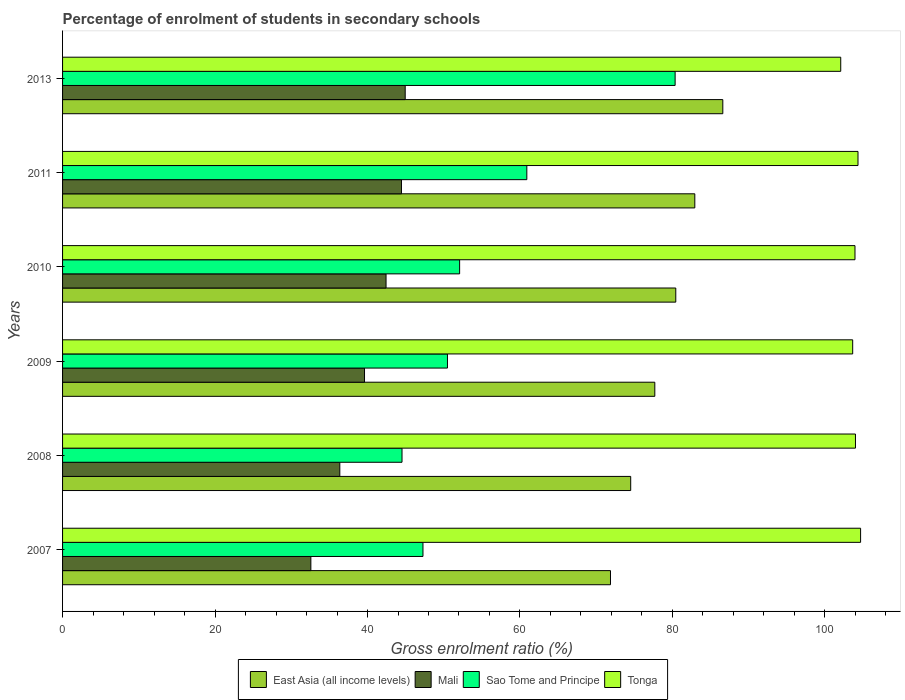How many different coloured bars are there?
Your answer should be compact. 4. How many groups of bars are there?
Provide a short and direct response. 6. Are the number of bars per tick equal to the number of legend labels?
Make the answer very short. Yes. Are the number of bars on each tick of the Y-axis equal?
Provide a short and direct response. Yes. How many bars are there on the 2nd tick from the top?
Keep it short and to the point. 4. How many bars are there on the 3rd tick from the bottom?
Offer a very short reply. 4. In how many cases, is the number of bars for a given year not equal to the number of legend labels?
Your response must be concise. 0. What is the percentage of students enrolled in secondary schools in Sao Tome and Principe in 2010?
Provide a short and direct response. 52.08. Across all years, what is the maximum percentage of students enrolled in secondary schools in East Asia (all income levels)?
Provide a short and direct response. 86.61. Across all years, what is the minimum percentage of students enrolled in secondary schools in Sao Tome and Principe?
Make the answer very short. 44.53. In which year was the percentage of students enrolled in secondary schools in Sao Tome and Principe maximum?
Offer a very short reply. 2013. In which year was the percentage of students enrolled in secondary schools in Tonga minimum?
Your answer should be compact. 2013. What is the total percentage of students enrolled in secondary schools in Sao Tome and Principe in the graph?
Give a very brief answer. 335.63. What is the difference between the percentage of students enrolled in secondary schools in Sao Tome and Principe in 2007 and that in 2010?
Your answer should be very brief. -4.81. What is the difference between the percentage of students enrolled in secondary schools in East Asia (all income levels) in 2009 and the percentage of students enrolled in secondary schools in Tonga in 2013?
Provide a short and direct response. -24.39. What is the average percentage of students enrolled in secondary schools in East Asia (all income levels) per year?
Give a very brief answer. 79.01. In the year 2007, what is the difference between the percentage of students enrolled in secondary schools in Sao Tome and Principe and percentage of students enrolled in secondary schools in East Asia (all income levels)?
Offer a terse response. -24.6. In how many years, is the percentage of students enrolled in secondary schools in Mali greater than 76 %?
Ensure brevity in your answer.  0. What is the ratio of the percentage of students enrolled in secondary schools in Sao Tome and Principe in 2008 to that in 2010?
Your answer should be very brief. 0.85. Is the percentage of students enrolled in secondary schools in Sao Tome and Principe in 2007 less than that in 2008?
Your response must be concise. No. Is the difference between the percentage of students enrolled in secondary schools in Sao Tome and Principe in 2008 and 2010 greater than the difference between the percentage of students enrolled in secondary schools in East Asia (all income levels) in 2008 and 2010?
Give a very brief answer. No. What is the difference between the highest and the second highest percentage of students enrolled in secondary schools in East Asia (all income levels)?
Make the answer very short. 3.67. What is the difference between the highest and the lowest percentage of students enrolled in secondary schools in Mali?
Your answer should be compact. 12.38. Is the sum of the percentage of students enrolled in secondary schools in Sao Tome and Principe in 2007 and 2008 greater than the maximum percentage of students enrolled in secondary schools in Tonga across all years?
Keep it short and to the point. No. Is it the case that in every year, the sum of the percentage of students enrolled in secondary schools in East Asia (all income levels) and percentage of students enrolled in secondary schools in Sao Tome and Principe is greater than the sum of percentage of students enrolled in secondary schools in Mali and percentage of students enrolled in secondary schools in Tonga?
Offer a very short reply. No. What does the 2nd bar from the top in 2009 represents?
Ensure brevity in your answer.  Sao Tome and Principe. What does the 3rd bar from the bottom in 2013 represents?
Offer a terse response. Sao Tome and Principe. Is it the case that in every year, the sum of the percentage of students enrolled in secondary schools in Sao Tome and Principe and percentage of students enrolled in secondary schools in Tonga is greater than the percentage of students enrolled in secondary schools in Mali?
Offer a terse response. Yes. Are the values on the major ticks of X-axis written in scientific E-notation?
Your answer should be very brief. No. Does the graph contain any zero values?
Ensure brevity in your answer.  No. Does the graph contain grids?
Keep it short and to the point. No. Where does the legend appear in the graph?
Offer a terse response. Bottom center. How many legend labels are there?
Your response must be concise. 4. How are the legend labels stacked?
Offer a very short reply. Horizontal. What is the title of the graph?
Keep it short and to the point. Percentage of enrolment of students in secondary schools. What is the label or title of the Y-axis?
Provide a succinct answer. Years. What is the Gross enrolment ratio (%) of East Asia (all income levels) in 2007?
Offer a terse response. 71.87. What is the Gross enrolment ratio (%) in Mali in 2007?
Make the answer very short. 32.57. What is the Gross enrolment ratio (%) in Sao Tome and Principe in 2007?
Your answer should be very brief. 47.28. What is the Gross enrolment ratio (%) of Tonga in 2007?
Offer a very short reply. 104.68. What is the Gross enrolment ratio (%) in East Asia (all income levels) in 2008?
Keep it short and to the point. 74.53. What is the Gross enrolment ratio (%) of Mali in 2008?
Make the answer very short. 36.37. What is the Gross enrolment ratio (%) of Sao Tome and Principe in 2008?
Make the answer very short. 44.53. What is the Gross enrolment ratio (%) of Tonga in 2008?
Keep it short and to the point. 104.01. What is the Gross enrolment ratio (%) of East Asia (all income levels) in 2009?
Make the answer very short. 77.69. What is the Gross enrolment ratio (%) of Mali in 2009?
Provide a succinct answer. 39.61. What is the Gross enrolment ratio (%) in Sao Tome and Principe in 2009?
Provide a short and direct response. 50.49. What is the Gross enrolment ratio (%) of Tonga in 2009?
Your response must be concise. 103.64. What is the Gross enrolment ratio (%) of East Asia (all income levels) in 2010?
Ensure brevity in your answer.  80.44. What is the Gross enrolment ratio (%) of Mali in 2010?
Give a very brief answer. 42.43. What is the Gross enrolment ratio (%) in Sao Tome and Principe in 2010?
Your answer should be compact. 52.08. What is the Gross enrolment ratio (%) of Tonga in 2010?
Give a very brief answer. 103.95. What is the Gross enrolment ratio (%) in East Asia (all income levels) in 2011?
Offer a very short reply. 82.94. What is the Gross enrolment ratio (%) of Mali in 2011?
Ensure brevity in your answer.  44.46. What is the Gross enrolment ratio (%) in Sao Tome and Principe in 2011?
Your answer should be very brief. 60.9. What is the Gross enrolment ratio (%) of Tonga in 2011?
Keep it short and to the point. 104.34. What is the Gross enrolment ratio (%) of East Asia (all income levels) in 2013?
Provide a short and direct response. 86.61. What is the Gross enrolment ratio (%) of Mali in 2013?
Give a very brief answer. 44.95. What is the Gross enrolment ratio (%) in Sao Tome and Principe in 2013?
Provide a short and direct response. 80.35. What is the Gross enrolment ratio (%) in Tonga in 2013?
Your response must be concise. 102.08. Across all years, what is the maximum Gross enrolment ratio (%) of East Asia (all income levels)?
Give a very brief answer. 86.61. Across all years, what is the maximum Gross enrolment ratio (%) of Mali?
Make the answer very short. 44.95. Across all years, what is the maximum Gross enrolment ratio (%) of Sao Tome and Principe?
Your answer should be very brief. 80.35. Across all years, what is the maximum Gross enrolment ratio (%) of Tonga?
Provide a short and direct response. 104.68. Across all years, what is the minimum Gross enrolment ratio (%) in East Asia (all income levels)?
Offer a terse response. 71.87. Across all years, what is the minimum Gross enrolment ratio (%) of Mali?
Provide a succinct answer. 32.57. Across all years, what is the minimum Gross enrolment ratio (%) in Sao Tome and Principe?
Offer a very short reply. 44.53. Across all years, what is the minimum Gross enrolment ratio (%) of Tonga?
Provide a succinct answer. 102.08. What is the total Gross enrolment ratio (%) in East Asia (all income levels) in the graph?
Your answer should be very brief. 474.07. What is the total Gross enrolment ratio (%) in Mali in the graph?
Provide a short and direct response. 240.38. What is the total Gross enrolment ratio (%) in Sao Tome and Principe in the graph?
Make the answer very short. 335.63. What is the total Gross enrolment ratio (%) of Tonga in the graph?
Provide a short and direct response. 622.7. What is the difference between the Gross enrolment ratio (%) in East Asia (all income levels) in 2007 and that in 2008?
Ensure brevity in your answer.  -2.65. What is the difference between the Gross enrolment ratio (%) in Mali in 2007 and that in 2008?
Keep it short and to the point. -3.8. What is the difference between the Gross enrolment ratio (%) of Sao Tome and Principe in 2007 and that in 2008?
Make the answer very short. 2.75. What is the difference between the Gross enrolment ratio (%) of Tonga in 2007 and that in 2008?
Your response must be concise. 0.67. What is the difference between the Gross enrolment ratio (%) of East Asia (all income levels) in 2007 and that in 2009?
Keep it short and to the point. -5.82. What is the difference between the Gross enrolment ratio (%) in Mali in 2007 and that in 2009?
Your response must be concise. -7.04. What is the difference between the Gross enrolment ratio (%) in Sao Tome and Principe in 2007 and that in 2009?
Offer a terse response. -3.22. What is the difference between the Gross enrolment ratio (%) of Tonga in 2007 and that in 2009?
Your response must be concise. 1.04. What is the difference between the Gross enrolment ratio (%) in East Asia (all income levels) in 2007 and that in 2010?
Provide a short and direct response. -8.57. What is the difference between the Gross enrolment ratio (%) in Mali in 2007 and that in 2010?
Offer a terse response. -9.86. What is the difference between the Gross enrolment ratio (%) of Sao Tome and Principe in 2007 and that in 2010?
Offer a very short reply. -4.81. What is the difference between the Gross enrolment ratio (%) in Tonga in 2007 and that in 2010?
Give a very brief answer. 0.73. What is the difference between the Gross enrolment ratio (%) in East Asia (all income levels) in 2007 and that in 2011?
Provide a short and direct response. -11.06. What is the difference between the Gross enrolment ratio (%) of Mali in 2007 and that in 2011?
Give a very brief answer. -11.88. What is the difference between the Gross enrolment ratio (%) in Sao Tome and Principe in 2007 and that in 2011?
Provide a short and direct response. -13.62. What is the difference between the Gross enrolment ratio (%) in Tonga in 2007 and that in 2011?
Provide a succinct answer. 0.34. What is the difference between the Gross enrolment ratio (%) in East Asia (all income levels) in 2007 and that in 2013?
Provide a short and direct response. -14.73. What is the difference between the Gross enrolment ratio (%) in Mali in 2007 and that in 2013?
Give a very brief answer. -12.38. What is the difference between the Gross enrolment ratio (%) of Sao Tome and Principe in 2007 and that in 2013?
Give a very brief answer. -33.08. What is the difference between the Gross enrolment ratio (%) in Tonga in 2007 and that in 2013?
Give a very brief answer. 2.6. What is the difference between the Gross enrolment ratio (%) in East Asia (all income levels) in 2008 and that in 2009?
Your answer should be very brief. -3.16. What is the difference between the Gross enrolment ratio (%) in Mali in 2008 and that in 2009?
Your answer should be compact. -3.24. What is the difference between the Gross enrolment ratio (%) in Sao Tome and Principe in 2008 and that in 2009?
Offer a very short reply. -5.96. What is the difference between the Gross enrolment ratio (%) in Tonga in 2008 and that in 2009?
Offer a terse response. 0.36. What is the difference between the Gross enrolment ratio (%) in East Asia (all income levels) in 2008 and that in 2010?
Make the answer very short. -5.91. What is the difference between the Gross enrolment ratio (%) of Mali in 2008 and that in 2010?
Offer a very short reply. -6.07. What is the difference between the Gross enrolment ratio (%) of Sao Tome and Principe in 2008 and that in 2010?
Provide a succinct answer. -7.56. What is the difference between the Gross enrolment ratio (%) in Tonga in 2008 and that in 2010?
Your response must be concise. 0.06. What is the difference between the Gross enrolment ratio (%) in East Asia (all income levels) in 2008 and that in 2011?
Provide a succinct answer. -8.41. What is the difference between the Gross enrolment ratio (%) of Mali in 2008 and that in 2011?
Your response must be concise. -8.09. What is the difference between the Gross enrolment ratio (%) in Sao Tome and Principe in 2008 and that in 2011?
Offer a very short reply. -16.37. What is the difference between the Gross enrolment ratio (%) in Tonga in 2008 and that in 2011?
Keep it short and to the point. -0.33. What is the difference between the Gross enrolment ratio (%) in East Asia (all income levels) in 2008 and that in 2013?
Your response must be concise. -12.08. What is the difference between the Gross enrolment ratio (%) in Mali in 2008 and that in 2013?
Provide a short and direct response. -8.58. What is the difference between the Gross enrolment ratio (%) in Sao Tome and Principe in 2008 and that in 2013?
Offer a terse response. -35.83. What is the difference between the Gross enrolment ratio (%) of Tonga in 2008 and that in 2013?
Your answer should be compact. 1.93. What is the difference between the Gross enrolment ratio (%) in East Asia (all income levels) in 2009 and that in 2010?
Offer a very short reply. -2.75. What is the difference between the Gross enrolment ratio (%) of Mali in 2009 and that in 2010?
Give a very brief answer. -2.83. What is the difference between the Gross enrolment ratio (%) in Sao Tome and Principe in 2009 and that in 2010?
Make the answer very short. -1.59. What is the difference between the Gross enrolment ratio (%) in Tonga in 2009 and that in 2010?
Give a very brief answer. -0.3. What is the difference between the Gross enrolment ratio (%) in East Asia (all income levels) in 2009 and that in 2011?
Ensure brevity in your answer.  -5.25. What is the difference between the Gross enrolment ratio (%) of Mali in 2009 and that in 2011?
Make the answer very short. -4.85. What is the difference between the Gross enrolment ratio (%) in Sao Tome and Principe in 2009 and that in 2011?
Offer a terse response. -10.41. What is the difference between the Gross enrolment ratio (%) of Tonga in 2009 and that in 2011?
Your answer should be very brief. -0.7. What is the difference between the Gross enrolment ratio (%) in East Asia (all income levels) in 2009 and that in 2013?
Your response must be concise. -8.92. What is the difference between the Gross enrolment ratio (%) in Mali in 2009 and that in 2013?
Keep it short and to the point. -5.34. What is the difference between the Gross enrolment ratio (%) in Sao Tome and Principe in 2009 and that in 2013?
Offer a very short reply. -29.86. What is the difference between the Gross enrolment ratio (%) of Tonga in 2009 and that in 2013?
Provide a succinct answer. 1.57. What is the difference between the Gross enrolment ratio (%) in East Asia (all income levels) in 2010 and that in 2011?
Offer a very short reply. -2.5. What is the difference between the Gross enrolment ratio (%) in Mali in 2010 and that in 2011?
Keep it short and to the point. -2.02. What is the difference between the Gross enrolment ratio (%) in Sao Tome and Principe in 2010 and that in 2011?
Give a very brief answer. -8.82. What is the difference between the Gross enrolment ratio (%) in Tonga in 2010 and that in 2011?
Keep it short and to the point. -0.4. What is the difference between the Gross enrolment ratio (%) in East Asia (all income levels) in 2010 and that in 2013?
Provide a short and direct response. -6.17. What is the difference between the Gross enrolment ratio (%) of Mali in 2010 and that in 2013?
Your answer should be compact. -2.51. What is the difference between the Gross enrolment ratio (%) in Sao Tome and Principe in 2010 and that in 2013?
Keep it short and to the point. -28.27. What is the difference between the Gross enrolment ratio (%) of Tonga in 2010 and that in 2013?
Provide a short and direct response. 1.87. What is the difference between the Gross enrolment ratio (%) of East Asia (all income levels) in 2011 and that in 2013?
Give a very brief answer. -3.67. What is the difference between the Gross enrolment ratio (%) of Mali in 2011 and that in 2013?
Provide a succinct answer. -0.49. What is the difference between the Gross enrolment ratio (%) in Sao Tome and Principe in 2011 and that in 2013?
Provide a short and direct response. -19.45. What is the difference between the Gross enrolment ratio (%) of Tonga in 2011 and that in 2013?
Offer a very short reply. 2.27. What is the difference between the Gross enrolment ratio (%) of East Asia (all income levels) in 2007 and the Gross enrolment ratio (%) of Mali in 2008?
Keep it short and to the point. 35.5. What is the difference between the Gross enrolment ratio (%) of East Asia (all income levels) in 2007 and the Gross enrolment ratio (%) of Sao Tome and Principe in 2008?
Offer a terse response. 27.35. What is the difference between the Gross enrolment ratio (%) in East Asia (all income levels) in 2007 and the Gross enrolment ratio (%) in Tonga in 2008?
Your response must be concise. -32.14. What is the difference between the Gross enrolment ratio (%) of Mali in 2007 and the Gross enrolment ratio (%) of Sao Tome and Principe in 2008?
Keep it short and to the point. -11.96. What is the difference between the Gross enrolment ratio (%) of Mali in 2007 and the Gross enrolment ratio (%) of Tonga in 2008?
Provide a succinct answer. -71.44. What is the difference between the Gross enrolment ratio (%) in Sao Tome and Principe in 2007 and the Gross enrolment ratio (%) in Tonga in 2008?
Offer a very short reply. -56.73. What is the difference between the Gross enrolment ratio (%) of East Asia (all income levels) in 2007 and the Gross enrolment ratio (%) of Mali in 2009?
Provide a short and direct response. 32.27. What is the difference between the Gross enrolment ratio (%) of East Asia (all income levels) in 2007 and the Gross enrolment ratio (%) of Sao Tome and Principe in 2009?
Your response must be concise. 21.38. What is the difference between the Gross enrolment ratio (%) of East Asia (all income levels) in 2007 and the Gross enrolment ratio (%) of Tonga in 2009?
Provide a short and direct response. -31.77. What is the difference between the Gross enrolment ratio (%) of Mali in 2007 and the Gross enrolment ratio (%) of Sao Tome and Principe in 2009?
Offer a very short reply. -17.92. What is the difference between the Gross enrolment ratio (%) in Mali in 2007 and the Gross enrolment ratio (%) in Tonga in 2009?
Offer a very short reply. -71.07. What is the difference between the Gross enrolment ratio (%) in Sao Tome and Principe in 2007 and the Gross enrolment ratio (%) in Tonga in 2009?
Your answer should be very brief. -56.37. What is the difference between the Gross enrolment ratio (%) of East Asia (all income levels) in 2007 and the Gross enrolment ratio (%) of Mali in 2010?
Provide a short and direct response. 29.44. What is the difference between the Gross enrolment ratio (%) in East Asia (all income levels) in 2007 and the Gross enrolment ratio (%) in Sao Tome and Principe in 2010?
Give a very brief answer. 19.79. What is the difference between the Gross enrolment ratio (%) of East Asia (all income levels) in 2007 and the Gross enrolment ratio (%) of Tonga in 2010?
Your answer should be compact. -32.07. What is the difference between the Gross enrolment ratio (%) in Mali in 2007 and the Gross enrolment ratio (%) in Sao Tome and Principe in 2010?
Provide a succinct answer. -19.51. What is the difference between the Gross enrolment ratio (%) in Mali in 2007 and the Gross enrolment ratio (%) in Tonga in 2010?
Make the answer very short. -71.38. What is the difference between the Gross enrolment ratio (%) of Sao Tome and Principe in 2007 and the Gross enrolment ratio (%) of Tonga in 2010?
Your answer should be compact. -56.67. What is the difference between the Gross enrolment ratio (%) of East Asia (all income levels) in 2007 and the Gross enrolment ratio (%) of Mali in 2011?
Offer a very short reply. 27.42. What is the difference between the Gross enrolment ratio (%) of East Asia (all income levels) in 2007 and the Gross enrolment ratio (%) of Sao Tome and Principe in 2011?
Offer a terse response. 10.97. What is the difference between the Gross enrolment ratio (%) in East Asia (all income levels) in 2007 and the Gross enrolment ratio (%) in Tonga in 2011?
Keep it short and to the point. -32.47. What is the difference between the Gross enrolment ratio (%) in Mali in 2007 and the Gross enrolment ratio (%) in Sao Tome and Principe in 2011?
Your answer should be compact. -28.33. What is the difference between the Gross enrolment ratio (%) in Mali in 2007 and the Gross enrolment ratio (%) in Tonga in 2011?
Ensure brevity in your answer.  -71.77. What is the difference between the Gross enrolment ratio (%) in Sao Tome and Principe in 2007 and the Gross enrolment ratio (%) in Tonga in 2011?
Provide a succinct answer. -57.07. What is the difference between the Gross enrolment ratio (%) in East Asia (all income levels) in 2007 and the Gross enrolment ratio (%) in Mali in 2013?
Your response must be concise. 26.93. What is the difference between the Gross enrolment ratio (%) of East Asia (all income levels) in 2007 and the Gross enrolment ratio (%) of Sao Tome and Principe in 2013?
Provide a short and direct response. -8.48. What is the difference between the Gross enrolment ratio (%) in East Asia (all income levels) in 2007 and the Gross enrolment ratio (%) in Tonga in 2013?
Give a very brief answer. -30.2. What is the difference between the Gross enrolment ratio (%) of Mali in 2007 and the Gross enrolment ratio (%) of Sao Tome and Principe in 2013?
Provide a short and direct response. -47.78. What is the difference between the Gross enrolment ratio (%) of Mali in 2007 and the Gross enrolment ratio (%) of Tonga in 2013?
Offer a terse response. -69.51. What is the difference between the Gross enrolment ratio (%) of Sao Tome and Principe in 2007 and the Gross enrolment ratio (%) of Tonga in 2013?
Provide a short and direct response. -54.8. What is the difference between the Gross enrolment ratio (%) of East Asia (all income levels) in 2008 and the Gross enrolment ratio (%) of Mali in 2009?
Provide a short and direct response. 34.92. What is the difference between the Gross enrolment ratio (%) of East Asia (all income levels) in 2008 and the Gross enrolment ratio (%) of Sao Tome and Principe in 2009?
Make the answer very short. 24.04. What is the difference between the Gross enrolment ratio (%) of East Asia (all income levels) in 2008 and the Gross enrolment ratio (%) of Tonga in 2009?
Offer a terse response. -29.12. What is the difference between the Gross enrolment ratio (%) of Mali in 2008 and the Gross enrolment ratio (%) of Sao Tome and Principe in 2009?
Provide a succinct answer. -14.12. What is the difference between the Gross enrolment ratio (%) in Mali in 2008 and the Gross enrolment ratio (%) in Tonga in 2009?
Your response must be concise. -67.28. What is the difference between the Gross enrolment ratio (%) in Sao Tome and Principe in 2008 and the Gross enrolment ratio (%) in Tonga in 2009?
Offer a terse response. -59.12. What is the difference between the Gross enrolment ratio (%) of East Asia (all income levels) in 2008 and the Gross enrolment ratio (%) of Mali in 2010?
Your answer should be compact. 32.09. What is the difference between the Gross enrolment ratio (%) in East Asia (all income levels) in 2008 and the Gross enrolment ratio (%) in Sao Tome and Principe in 2010?
Your answer should be compact. 22.44. What is the difference between the Gross enrolment ratio (%) of East Asia (all income levels) in 2008 and the Gross enrolment ratio (%) of Tonga in 2010?
Offer a very short reply. -29.42. What is the difference between the Gross enrolment ratio (%) of Mali in 2008 and the Gross enrolment ratio (%) of Sao Tome and Principe in 2010?
Offer a terse response. -15.72. What is the difference between the Gross enrolment ratio (%) of Mali in 2008 and the Gross enrolment ratio (%) of Tonga in 2010?
Provide a short and direct response. -67.58. What is the difference between the Gross enrolment ratio (%) in Sao Tome and Principe in 2008 and the Gross enrolment ratio (%) in Tonga in 2010?
Your answer should be very brief. -59.42. What is the difference between the Gross enrolment ratio (%) in East Asia (all income levels) in 2008 and the Gross enrolment ratio (%) in Mali in 2011?
Your answer should be very brief. 30.07. What is the difference between the Gross enrolment ratio (%) of East Asia (all income levels) in 2008 and the Gross enrolment ratio (%) of Sao Tome and Principe in 2011?
Provide a short and direct response. 13.63. What is the difference between the Gross enrolment ratio (%) of East Asia (all income levels) in 2008 and the Gross enrolment ratio (%) of Tonga in 2011?
Your answer should be compact. -29.82. What is the difference between the Gross enrolment ratio (%) of Mali in 2008 and the Gross enrolment ratio (%) of Sao Tome and Principe in 2011?
Keep it short and to the point. -24.53. What is the difference between the Gross enrolment ratio (%) in Mali in 2008 and the Gross enrolment ratio (%) in Tonga in 2011?
Provide a succinct answer. -67.97. What is the difference between the Gross enrolment ratio (%) in Sao Tome and Principe in 2008 and the Gross enrolment ratio (%) in Tonga in 2011?
Make the answer very short. -59.82. What is the difference between the Gross enrolment ratio (%) in East Asia (all income levels) in 2008 and the Gross enrolment ratio (%) in Mali in 2013?
Provide a succinct answer. 29.58. What is the difference between the Gross enrolment ratio (%) in East Asia (all income levels) in 2008 and the Gross enrolment ratio (%) in Sao Tome and Principe in 2013?
Make the answer very short. -5.83. What is the difference between the Gross enrolment ratio (%) of East Asia (all income levels) in 2008 and the Gross enrolment ratio (%) of Tonga in 2013?
Offer a terse response. -27.55. What is the difference between the Gross enrolment ratio (%) in Mali in 2008 and the Gross enrolment ratio (%) in Sao Tome and Principe in 2013?
Make the answer very short. -43.98. What is the difference between the Gross enrolment ratio (%) of Mali in 2008 and the Gross enrolment ratio (%) of Tonga in 2013?
Your response must be concise. -65.71. What is the difference between the Gross enrolment ratio (%) in Sao Tome and Principe in 2008 and the Gross enrolment ratio (%) in Tonga in 2013?
Your answer should be very brief. -57.55. What is the difference between the Gross enrolment ratio (%) in East Asia (all income levels) in 2009 and the Gross enrolment ratio (%) in Mali in 2010?
Make the answer very short. 35.26. What is the difference between the Gross enrolment ratio (%) in East Asia (all income levels) in 2009 and the Gross enrolment ratio (%) in Sao Tome and Principe in 2010?
Keep it short and to the point. 25.6. What is the difference between the Gross enrolment ratio (%) of East Asia (all income levels) in 2009 and the Gross enrolment ratio (%) of Tonga in 2010?
Offer a very short reply. -26.26. What is the difference between the Gross enrolment ratio (%) in Mali in 2009 and the Gross enrolment ratio (%) in Sao Tome and Principe in 2010?
Your answer should be compact. -12.48. What is the difference between the Gross enrolment ratio (%) in Mali in 2009 and the Gross enrolment ratio (%) in Tonga in 2010?
Ensure brevity in your answer.  -64.34. What is the difference between the Gross enrolment ratio (%) of Sao Tome and Principe in 2009 and the Gross enrolment ratio (%) of Tonga in 2010?
Give a very brief answer. -53.46. What is the difference between the Gross enrolment ratio (%) in East Asia (all income levels) in 2009 and the Gross enrolment ratio (%) in Mali in 2011?
Keep it short and to the point. 33.23. What is the difference between the Gross enrolment ratio (%) of East Asia (all income levels) in 2009 and the Gross enrolment ratio (%) of Sao Tome and Principe in 2011?
Make the answer very short. 16.79. What is the difference between the Gross enrolment ratio (%) in East Asia (all income levels) in 2009 and the Gross enrolment ratio (%) in Tonga in 2011?
Keep it short and to the point. -26.65. What is the difference between the Gross enrolment ratio (%) in Mali in 2009 and the Gross enrolment ratio (%) in Sao Tome and Principe in 2011?
Offer a terse response. -21.29. What is the difference between the Gross enrolment ratio (%) of Mali in 2009 and the Gross enrolment ratio (%) of Tonga in 2011?
Make the answer very short. -64.73. What is the difference between the Gross enrolment ratio (%) of Sao Tome and Principe in 2009 and the Gross enrolment ratio (%) of Tonga in 2011?
Keep it short and to the point. -53.85. What is the difference between the Gross enrolment ratio (%) in East Asia (all income levels) in 2009 and the Gross enrolment ratio (%) in Mali in 2013?
Offer a terse response. 32.74. What is the difference between the Gross enrolment ratio (%) in East Asia (all income levels) in 2009 and the Gross enrolment ratio (%) in Sao Tome and Principe in 2013?
Your answer should be very brief. -2.66. What is the difference between the Gross enrolment ratio (%) in East Asia (all income levels) in 2009 and the Gross enrolment ratio (%) in Tonga in 2013?
Keep it short and to the point. -24.39. What is the difference between the Gross enrolment ratio (%) in Mali in 2009 and the Gross enrolment ratio (%) in Sao Tome and Principe in 2013?
Your answer should be very brief. -40.75. What is the difference between the Gross enrolment ratio (%) of Mali in 2009 and the Gross enrolment ratio (%) of Tonga in 2013?
Your response must be concise. -62.47. What is the difference between the Gross enrolment ratio (%) of Sao Tome and Principe in 2009 and the Gross enrolment ratio (%) of Tonga in 2013?
Your answer should be compact. -51.59. What is the difference between the Gross enrolment ratio (%) in East Asia (all income levels) in 2010 and the Gross enrolment ratio (%) in Mali in 2011?
Offer a terse response. 35.98. What is the difference between the Gross enrolment ratio (%) of East Asia (all income levels) in 2010 and the Gross enrolment ratio (%) of Sao Tome and Principe in 2011?
Ensure brevity in your answer.  19.54. What is the difference between the Gross enrolment ratio (%) in East Asia (all income levels) in 2010 and the Gross enrolment ratio (%) in Tonga in 2011?
Offer a terse response. -23.9. What is the difference between the Gross enrolment ratio (%) in Mali in 2010 and the Gross enrolment ratio (%) in Sao Tome and Principe in 2011?
Your answer should be very brief. -18.47. What is the difference between the Gross enrolment ratio (%) of Mali in 2010 and the Gross enrolment ratio (%) of Tonga in 2011?
Your answer should be compact. -61.91. What is the difference between the Gross enrolment ratio (%) of Sao Tome and Principe in 2010 and the Gross enrolment ratio (%) of Tonga in 2011?
Give a very brief answer. -52.26. What is the difference between the Gross enrolment ratio (%) of East Asia (all income levels) in 2010 and the Gross enrolment ratio (%) of Mali in 2013?
Your response must be concise. 35.49. What is the difference between the Gross enrolment ratio (%) in East Asia (all income levels) in 2010 and the Gross enrolment ratio (%) in Sao Tome and Principe in 2013?
Your answer should be compact. 0.09. What is the difference between the Gross enrolment ratio (%) in East Asia (all income levels) in 2010 and the Gross enrolment ratio (%) in Tonga in 2013?
Make the answer very short. -21.64. What is the difference between the Gross enrolment ratio (%) in Mali in 2010 and the Gross enrolment ratio (%) in Sao Tome and Principe in 2013?
Provide a short and direct response. -37.92. What is the difference between the Gross enrolment ratio (%) in Mali in 2010 and the Gross enrolment ratio (%) in Tonga in 2013?
Ensure brevity in your answer.  -59.64. What is the difference between the Gross enrolment ratio (%) in Sao Tome and Principe in 2010 and the Gross enrolment ratio (%) in Tonga in 2013?
Keep it short and to the point. -49.99. What is the difference between the Gross enrolment ratio (%) of East Asia (all income levels) in 2011 and the Gross enrolment ratio (%) of Mali in 2013?
Offer a terse response. 37.99. What is the difference between the Gross enrolment ratio (%) in East Asia (all income levels) in 2011 and the Gross enrolment ratio (%) in Sao Tome and Principe in 2013?
Offer a very short reply. 2.58. What is the difference between the Gross enrolment ratio (%) in East Asia (all income levels) in 2011 and the Gross enrolment ratio (%) in Tonga in 2013?
Keep it short and to the point. -19.14. What is the difference between the Gross enrolment ratio (%) of Mali in 2011 and the Gross enrolment ratio (%) of Sao Tome and Principe in 2013?
Your response must be concise. -35.9. What is the difference between the Gross enrolment ratio (%) of Mali in 2011 and the Gross enrolment ratio (%) of Tonga in 2013?
Keep it short and to the point. -57.62. What is the difference between the Gross enrolment ratio (%) of Sao Tome and Principe in 2011 and the Gross enrolment ratio (%) of Tonga in 2013?
Offer a very short reply. -41.18. What is the average Gross enrolment ratio (%) of East Asia (all income levels) per year?
Your answer should be compact. 79.01. What is the average Gross enrolment ratio (%) of Mali per year?
Your response must be concise. 40.06. What is the average Gross enrolment ratio (%) of Sao Tome and Principe per year?
Your answer should be compact. 55.94. What is the average Gross enrolment ratio (%) in Tonga per year?
Offer a terse response. 103.78. In the year 2007, what is the difference between the Gross enrolment ratio (%) in East Asia (all income levels) and Gross enrolment ratio (%) in Mali?
Offer a terse response. 39.3. In the year 2007, what is the difference between the Gross enrolment ratio (%) of East Asia (all income levels) and Gross enrolment ratio (%) of Sao Tome and Principe?
Offer a terse response. 24.6. In the year 2007, what is the difference between the Gross enrolment ratio (%) of East Asia (all income levels) and Gross enrolment ratio (%) of Tonga?
Offer a very short reply. -32.81. In the year 2007, what is the difference between the Gross enrolment ratio (%) of Mali and Gross enrolment ratio (%) of Sao Tome and Principe?
Provide a succinct answer. -14.71. In the year 2007, what is the difference between the Gross enrolment ratio (%) of Mali and Gross enrolment ratio (%) of Tonga?
Ensure brevity in your answer.  -72.11. In the year 2007, what is the difference between the Gross enrolment ratio (%) in Sao Tome and Principe and Gross enrolment ratio (%) in Tonga?
Give a very brief answer. -57.41. In the year 2008, what is the difference between the Gross enrolment ratio (%) in East Asia (all income levels) and Gross enrolment ratio (%) in Mali?
Provide a short and direct response. 38.16. In the year 2008, what is the difference between the Gross enrolment ratio (%) in East Asia (all income levels) and Gross enrolment ratio (%) in Sao Tome and Principe?
Offer a terse response. 30. In the year 2008, what is the difference between the Gross enrolment ratio (%) of East Asia (all income levels) and Gross enrolment ratio (%) of Tonga?
Your response must be concise. -29.48. In the year 2008, what is the difference between the Gross enrolment ratio (%) of Mali and Gross enrolment ratio (%) of Sao Tome and Principe?
Make the answer very short. -8.16. In the year 2008, what is the difference between the Gross enrolment ratio (%) in Mali and Gross enrolment ratio (%) in Tonga?
Your answer should be compact. -67.64. In the year 2008, what is the difference between the Gross enrolment ratio (%) in Sao Tome and Principe and Gross enrolment ratio (%) in Tonga?
Ensure brevity in your answer.  -59.48. In the year 2009, what is the difference between the Gross enrolment ratio (%) of East Asia (all income levels) and Gross enrolment ratio (%) of Mali?
Your answer should be compact. 38.08. In the year 2009, what is the difference between the Gross enrolment ratio (%) in East Asia (all income levels) and Gross enrolment ratio (%) in Sao Tome and Principe?
Provide a short and direct response. 27.2. In the year 2009, what is the difference between the Gross enrolment ratio (%) of East Asia (all income levels) and Gross enrolment ratio (%) of Tonga?
Give a very brief answer. -25.96. In the year 2009, what is the difference between the Gross enrolment ratio (%) of Mali and Gross enrolment ratio (%) of Sao Tome and Principe?
Ensure brevity in your answer.  -10.88. In the year 2009, what is the difference between the Gross enrolment ratio (%) of Mali and Gross enrolment ratio (%) of Tonga?
Offer a terse response. -64.04. In the year 2009, what is the difference between the Gross enrolment ratio (%) in Sao Tome and Principe and Gross enrolment ratio (%) in Tonga?
Your answer should be compact. -53.15. In the year 2010, what is the difference between the Gross enrolment ratio (%) of East Asia (all income levels) and Gross enrolment ratio (%) of Mali?
Your response must be concise. 38.01. In the year 2010, what is the difference between the Gross enrolment ratio (%) of East Asia (all income levels) and Gross enrolment ratio (%) of Sao Tome and Principe?
Give a very brief answer. 28.36. In the year 2010, what is the difference between the Gross enrolment ratio (%) in East Asia (all income levels) and Gross enrolment ratio (%) in Tonga?
Provide a short and direct response. -23.51. In the year 2010, what is the difference between the Gross enrolment ratio (%) in Mali and Gross enrolment ratio (%) in Sao Tome and Principe?
Your response must be concise. -9.65. In the year 2010, what is the difference between the Gross enrolment ratio (%) in Mali and Gross enrolment ratio (%) in Tonga?
Your answer should be very brief. -61.51. In the year 2010, what is the difference between the Gross enrolment ratio (%) in Sao Tome and Principe and Gross enrolment ratio (%) in Tonga?
Offer a very short reply. -51.86. In the year 2011, what is the difference between the Gross enrolment ratio (%) in East Asia (all income levels) and Gross enrolment ratio (%) in Mali?
Offer a terse response. 38.48. In the year 2011, what is the difference between the Gross enrolment ratio (%) in East Asia (all income levels) and Gross enrolment ratio (%) in Sao Tome and Principe?
Keep it short and to the point. 22.04. In the year 2011, what is the difference between the Gross enrolment ratio (%) of East Asia (all income levels) and Gross enrolment ratio (%) of Tonga?
Your answer should be very brief. -21.41. In the year 2011, what is the difference between the Gross enrolment ratio (%) in Mali and Gross enrolment ratio (%) in Sao Tome and Principe?
Offer a very short reply. -16.44. In the year 2011, what is the difference between the Gross enrolment ratio (%) in Mali and Gross enrolment ratio (%) in Tonga?
Provide a succinct answer. -59.89. In the year 2011, what is the difference between the Gross enrolment ratio (%) of Sao Tome and Principe and Gross enrolment ratio (%) of Tonga?
Offer a terse response. -43.44. In the year 2013, what is the difference between the Gross enrolment ratio (%) of East Asia (all income levels) and Gross enrolment ratio (%) of Mali?
Offer a very short reply. 41.66. In the year 2013, what is the difference between the Gross enrolment ratio (%) in East Asia (all income levels) and Gross enrolment ratio (%) in Sao Tome and Principe?
Give a very brief answer. 6.25. In the year 2013, what is the difference between the Gross enrolment ratio (%) of East Asia (all income levels) and Gross enrolment ratio (%) of Tonga?
Offer a terse response. -15.47. In the year 2013, what is the difference between the Gross enrolment ratio (%) in Mali and Gross enrolment ratio (%) in Sao Tome and Principe?
Provide a succinct answer. -35.41. In the year 2013, what is the difference between the Gross enrolment ratio (%) in Mali and Gross enrolment ratio (%) in Tonga?
Your answer should be very brief. -57.13. In the year 2013, what is the difference between the Gross enrolment ratio (%) in Sao Tome and Principe and Gross enrolment ratio (%) in Tonga?
Provide a short and direct response. -21.72. What is the ratio of the Gross enrolment ratio (%) of East Asia (all income levels) in 2007 to that in 2008?
Provide a short and direct response. 0.96. What is the ratio of the Gross enrolment ratio (%) of Mali in 2007 to that in 2008?
Make the answer very short. 0.9. What is the ratio of the Gross enrolment ratio (%) in Sao Tome and Principe in 2007 to that in 2008?
Your answer should be very brief. 1.06. What is the ratio of the Gross enrolment ratio (%) in Tonga in 2007 to that in 2008?
Your answer should be compact. 1.01. What is the ratio of the Gross enrolment ratio (%) in East Asia (all income levels) in 2007 to that in 2009?
Give a very brief answer. 0.93. What is the ratio of the Gross enrolment ratio (%) in Mali in 2007 to that in 2009?
Provide a short and direct response. 0.82. What is the ratio of the Gross enrolment ratio (%) in Sao Tome and Principe in 2007 to that in 2009?
Give a very brief answer. 0.94. What is the ratio of the Gross enrolment ratio (%) in East Asia (all income levels) in 2007 to that in 2010?
Your answer should be compact. 0.89. What is the ratio of the Gross enrolment ratio (%) in Mali in 2007 to that in 2010?
Make the answer very short. 0.77. What is the ratio of the Gross enrolment ratio (%) in Sao Tome and Principe in 2007 to that in 2010?
Give a very brief answer. 0.91. What is the ratio of the Gross enrolment ratio (%) in Tonga in 2007 to that in 2010?
Make the answer very short. 1.01. What is the ratio of the Gross enrolment ratio (%) of East Asia (all income levels) in 2007 to that in 2011?
Make the answer very short. 0.87. What is the ratio of the Gross enrolment ratio (%) in Mali in 2007 to that in 2011?
Provide a short and direct response. 0.73. What is the ratio of the Gross enrolment ratio (%) in Sao Tome and Principe in 2007 to that in 2011?
Provide a short and direct response. 0.78. What is the ratio of the Gross enrolment ratio (%) of East Asia (all income levels) in 2007 to that in 2013?
Offer a very short reply. 0.83. What is the ratio of the Gross enrolment ratio (%) of Mali in 2007 to that in 2013?
Offer a terse response. 0.72. What is the ratio of the Gross enrolment ratio (%) in Sao Tome and Principe in 2007 to that in 2013?
Provide a succinct answer. 0.59. What is the ratio of the Gross enrolment ratio (%) in Tonga in 2007 to that in 2013?
Your answer should be compact. 1.03. What is the ratio of the Gross enrolment ratio (%) of East Asia (all income levels) in 2008 to that in 2009?
Your answer should be compact. 0.96. What is the ratio of the Gross enrolment ratio (%) of Mali in 2008 to that in 2009?
Your response must be concise. 0.92. What is the ratio of the Gross enrolment ratio (%) of Sao Tome and Principe in 2008 to that in 2009?
Your response must be concise. 0.88. What is the ratio of the Gross enrolment ratio (%) of East Asia (all income levels) in 2008 to that in 2010?
Offer a very short reply. 0.93. What is the ratio of the Gross enrolment ratio (%) of Mali in 2008 to that in 2010?
Your answer should be compact. 0.86. What is the ratio of the Gross enrolment ratio (%) in Sao Tome and Principe in 2008 to that in 2010?
Provide a succinct answer. 0.85. What is the ratio of the Gross enrolment ratio (%) of Tonga in 2008 to that in 2010?
Provide a succinct answer. 1. What is the ratio of the Gross enrolment ratio (%) of East Asia (all income levels) in 2008 to that in 2011?
Provide a short and direct response. 0.9. What is the ratio of the Gross enrolment ratio (%) in Mali in 2008 to that in 2011?
Offer a terse response. 0.82. What is the ratio of the Gross enrolment ratio (%) in Sao Tome and Principe in 2008 to that in 2011?
Offer a terse response. 0.73. What is the ratio of the Gross enrolment ratio (%) in Tonga in 2008 to that in 2011?
Your answer should be very brief. 1. What is the ratio of the Gross enrolment ratio (%) in East Asia (all income levels) in 2008 to that in 2013?
Make the answer very short. 0.86. What is the ratio of the Gross enrolment ratio (%) of Mali in 2008 to that in 2013?
Your answer should be very brief. 0.81. What is the ratio of the Gross enrolment ratio (%) of Sao Tome and Principe in 2008 to that in 2013?
Your answer should be compact. 0.55. What is the ratio of the Gross enrolment ratio (%) in Tonga in 2008 to that in 2013?
Keep it short and to the point. 1.02. What is the ratio of the Gross enrolment ratio (%) of East Asia (all income levels) in 2009 to that in 2010?
Provide a short and direct response. 0.97. What is the ratio of the Gross enrolment ratio (%) in Mali in 2009 to that in 2010?
Offer a very short reply. 0.93. What is the ratio of the Gross enrolment ratio (%) of Sao Tome and Principe in 2009 to that in 2010?
Your answer should be very brief. 0.97. What is the ratio of the Gross enrolment ratio (%) of Tonga in 2009 to that in 2010?
Ensure brevity in your answer.  1. What is the ratio of the Gross enrolment ratio (%) of East Asia (all income levels) in 2009 to that in 2011?
Ensure brevity in your answer.  0.94. What is the ratio of the Gross enrolment ratio (%) in Mali in 2009 to that in 2011?
Make the answer very short. 0.89. What is the ratio of the Gross enrolment ratio (%) in Sao Tome and Principe in 2009 to that in 2011?
Your response must be concise. 0.83. What is the ratio of the Gross enrolment ratio (%) of East Asia (all income levels) in 2009 to that in 2013?
Provide a short and direct response. 0.9. What is the ratio of the Gross enrolment ratio (%) of Mali in 2009 to that in 2013?
Keep it short and to the point. 0.88. What is the ratio of the Gross enrolment ratio (%) of Sao Tome and Principe in 2009 to that in 2013?
Offer a terse response. 0.63. What is the ratio of the Gross enrolment ratio (%) of Tonga in 2009 to that in 2013?
Give a very brief answer. 1.02. What is the ratio of the Gross enrolment ratio (%) in East Asia (all income levels) in 2010 to that in 2011?
Your answer should be very brief. 0.97. What is the ratio of the Gross enrolment ratio (%) in Mali in 2010 to that in 2011?
Provide a short and direct response. 0.95. What is the ratio of the Gross enrolment ratio (%) in Sao Tome and Principe in 2010 to that in 2011?
Provide a succinct answer. 0.86. What is the ratio of the Gross enrolment ratio (%) of East Asia (all income levels) in 2010 to that in 2013?
Your answer should be compact. 0.93. What is the ratio of the Gross enrolment ratio (%) in Mali in 2010 to that in 2013?
Your response must be concise. 0.94. What is the ratio of the Gross enrolment ratio (%) of Sao Tome and Principe in 2010 to that in 2013?
Offer a terse response. 0.65. What is the ratio of the Gross enrolment ratio (%) in Tonga in 2010 to that in 2013?
Offer a terse response. 1.02. What is the ratio of the Gross enrolment ratio (%) of East Asia (all income levels) in 2011 to that in 2013?
Your answer should be compact. 0.96. What is the ratio of the Gross enrolment ratio (%) of Mali in 2011 to that in 2013?
Provide a succinct answer. 0.99. What is the ratio of the Gross enrolment ratio (%) in Sao Tome and Principe in 2011 to that in 2013?
Make the answer very short. 0.76. What is the ratio of the Gross enrolment ratio (%) of Tonga in 2011 to that in 2013?
Offer a terse response. 1.02. What is the difference between the highest and the second highest Gross enrolment ratio (%) in East Asia (all income levels)?
Give a very brief answer. 3.67. What is the difference between the highest and the second highest Gross enrolment ratio (%) of Mali?
Provide a short and direct response. 0.49. What is the difference between the highest and the second highest Gross enrolment ratio (%) in Sao Tome and Principe?
Ensure brevity in your answer.  19.45. What is the difference between the highest and the second highest Gross enrolment ratio (%) in Tonga?
Provide a succinct answer. 0.34. What is the difference between the highest and the lowest Gross enrolment ratio (%) in East Asia (all income levels)?
Provide a succinct answer. 14.73. What is the difference between the highest and the lowest Gross enrolment ratio (%) of Mali?
Provide a succinct answer. 12.38. What is the difference between the highest and the lowest Gross enrolment ratio (%) of Sao Tome and Principe?
Provide a short and direct response. 35.83. What is the difference between the highest and the lowest Gross enrolment ratio (%) of Tonga?
Offer a terse response. 2.6. 